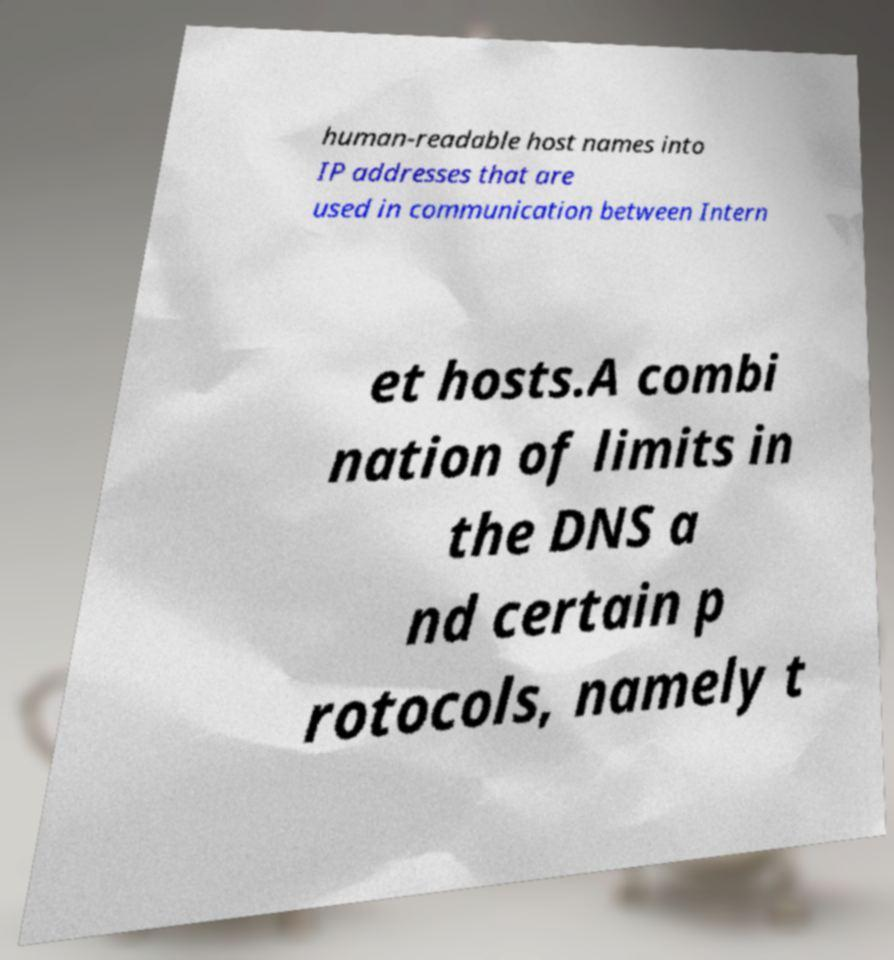What messages or text are displayed in this image? I need them in a readable, typed format. human-readable host names into IP addresses that are used in communication between Intern et hosts.A combi nation of limits in the DNS a nd certain p rotocols, namely t 